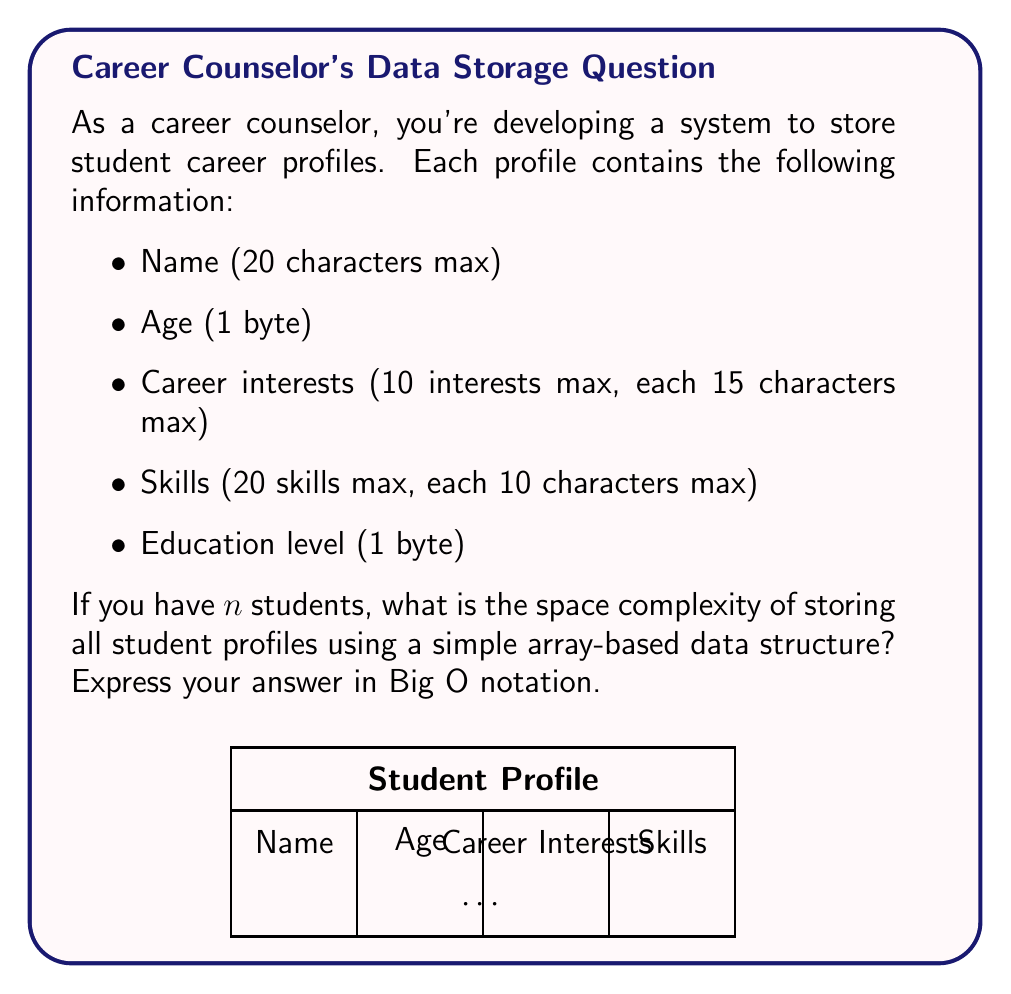Could you help me with this problem? Let's break down the space requirements for each component of a student profile:

1. Name: 20 characters * 1 byte per character = 20 bytes
2. Age: 1 byte
3. Career interests: 
   - 10 interests * 15 characters per interest * 1 byte per character = 150 bytes
4. Skills: 
   - 20 skills * 10 characters per skill * 1 byte per character = 200 bytes
5. Education level: 1 byte

Total space for one student profile:
$20 + 1 + 150 + 200 + 1 = 372$ bytes

For $n$ students, we multiply this by $n$:
$372n$ bytes

In Big O notation, we ignore constant factors, so the space complexity is $O(n)$.

This is because:
1. The space required grows linearly with the number of students.
2. Each student profile has a fixed maximum size, independent of $n$.
3. We're using a simple array-based structure, which doesn't introduce any additional space overhead that grows with $n$.

Therefore, the space complexity for storing $n$ student profiles is $O(n)$.
Answer: $O(n)$ 